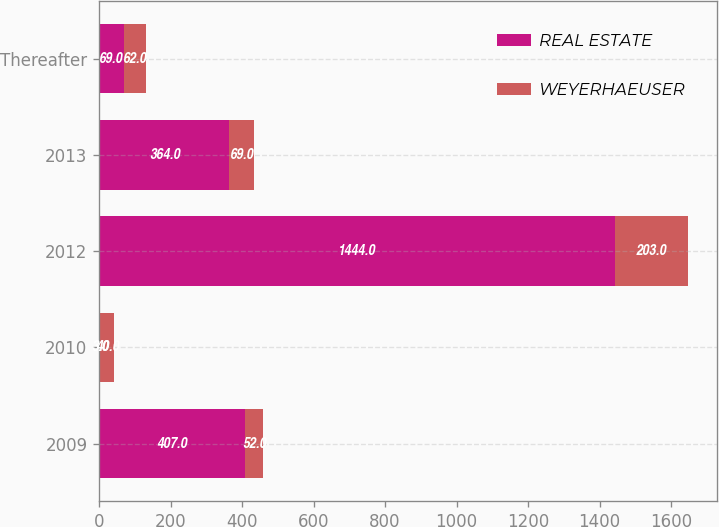<chart> <loc_0><loc_0><loc_500><loc_500><stacked_bar_chart><ecel><fcel>2009<fcel>2010<fcel>2012<fcel>2013<fcel>Thereafter<nl><fcel>REAL ESTATE<fcel>407<fcel>3<fcel>1444<fcel>364<fcel>69<nl><fcel>WEYERHAEUSER<fcel>52<fcel>40<fcel>203<fcel>69<fcel>62<nl></chart> 